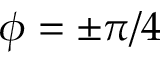<formula> <loc_0><loc_0><loc_500><loc_500>\phi = \pm \pi / 4</formula> 